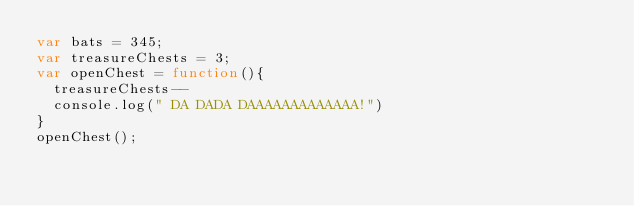<code> <loc_0><loc_0><loc_500><loc_500><_JavaScript_>var bats = 345;
var treasureChests = 3;
var openChest = function(){
  treasureChests--
  console.log(" DA DADA DAAAAAAAAAAAAA!")
}
openChest();
</code> 